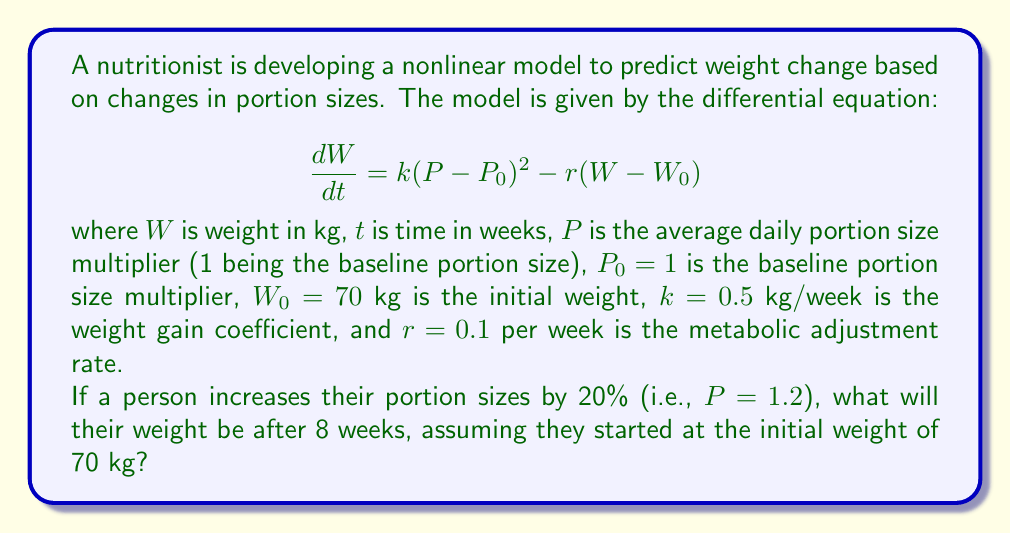Can you answer this question? To solve this problem, we need to use numerical methods to approximate the solution to the nonlinear differential equation. We'll use the Runge-Kutta 4th order method (RK4) to solve this problem.

Step 1: Set up the differential equation.
$$\frac{dW}{dt} = 0.5(1.2 - 1)^2 - 0.1(W - 70)$$
$$\frac{dW}{dt} = 0.5(0.2)^2 - 0.1(W - 70)$$
$$\frac{dW}{dt} = 0.02 - 0.1W + 7$$
$$\frac{dW}{dt} = 7.02 - 0.1W$$

Step 2: Define the RK4 method.
For a differential equation $\frac{dy}{dx} = f(x,y)$, the RK4 method is:

$$k_1 = hf(x_n, y_n)$$
$$k_2 = hf(x_n + \frac{h}{2}, y_n + \frac{k_1}{2})$$
$$k_3 = hf(x_n + \frac{h}{2}, y_n + \frac{k_2}{2})$$
$$k_4 = hf(x_n + h, y_n + k_3)$$
$$y_{n+1} = y_n + \frac{1}{6}(k_1 + 2k_2 + 2k_3 + k_4)$$

where $h$ is the step size.

Step 3: Implement the RK4 method.
Let's use a step size of $h = 1$ week and iterate 8 times.

Initial conditions: $t_0 = 0$, $W_0 = 70$

For each step:
$$k_1 = h(7.02 - 0.1W_n)$$
$$k_2 = h(7.02 - 0.1(W_n + \frac{k_1}{2}))$$
$$k_3 = h(7.02 - 0.1(W_n + \frac{k_2}{2}))$$
$$k_4 = h(7.02 - 0.1(W_n + k_3))$$
$$W_{n+1} = W_n + \frac{1}{6}(k_1 + 2k_2 + 2k_3 + k_4)$$

Step 4: Calculate the weight for each week.
Week 0: $W_0 = 70.00$ kg
Week 1: $W_1 = 70.65$ kg
Week 2: $W_2 = 71.24$ kg
Week 3: $W_3 = 71.77$ kg
Week 4: $W_4 = 72.25$ kg
Week 5: $W_5 = 72.68$ kg
Week 6: $W_6 = 73.07$ kg
Week 7: $W_7 = 73.42$ kg
Week 8: $W_8 = 73.73$ kg

Therefore, after 8 weeks, the person's weight will be approximately 73.73 kg.
Answer: 73.73 kg 